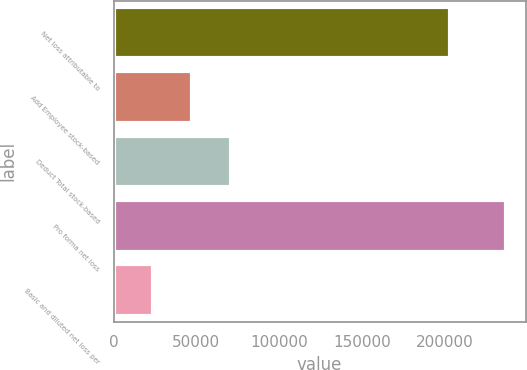Convert chart to OTSL. <chart><loc_0><loc_0><loc_500><loc_500><bar_chart><fcel>Net loss attributable to<fcel>Add Employee stock-based<fcel>Deduct Total stock-based<fcel>Pro forma net loss<fcel>Basic and diluted net loss per<nl><fcel>203417<fcel>47402.2<fcel>71102.2<fcel>237002<fcel>23702.2<nl></chart> 